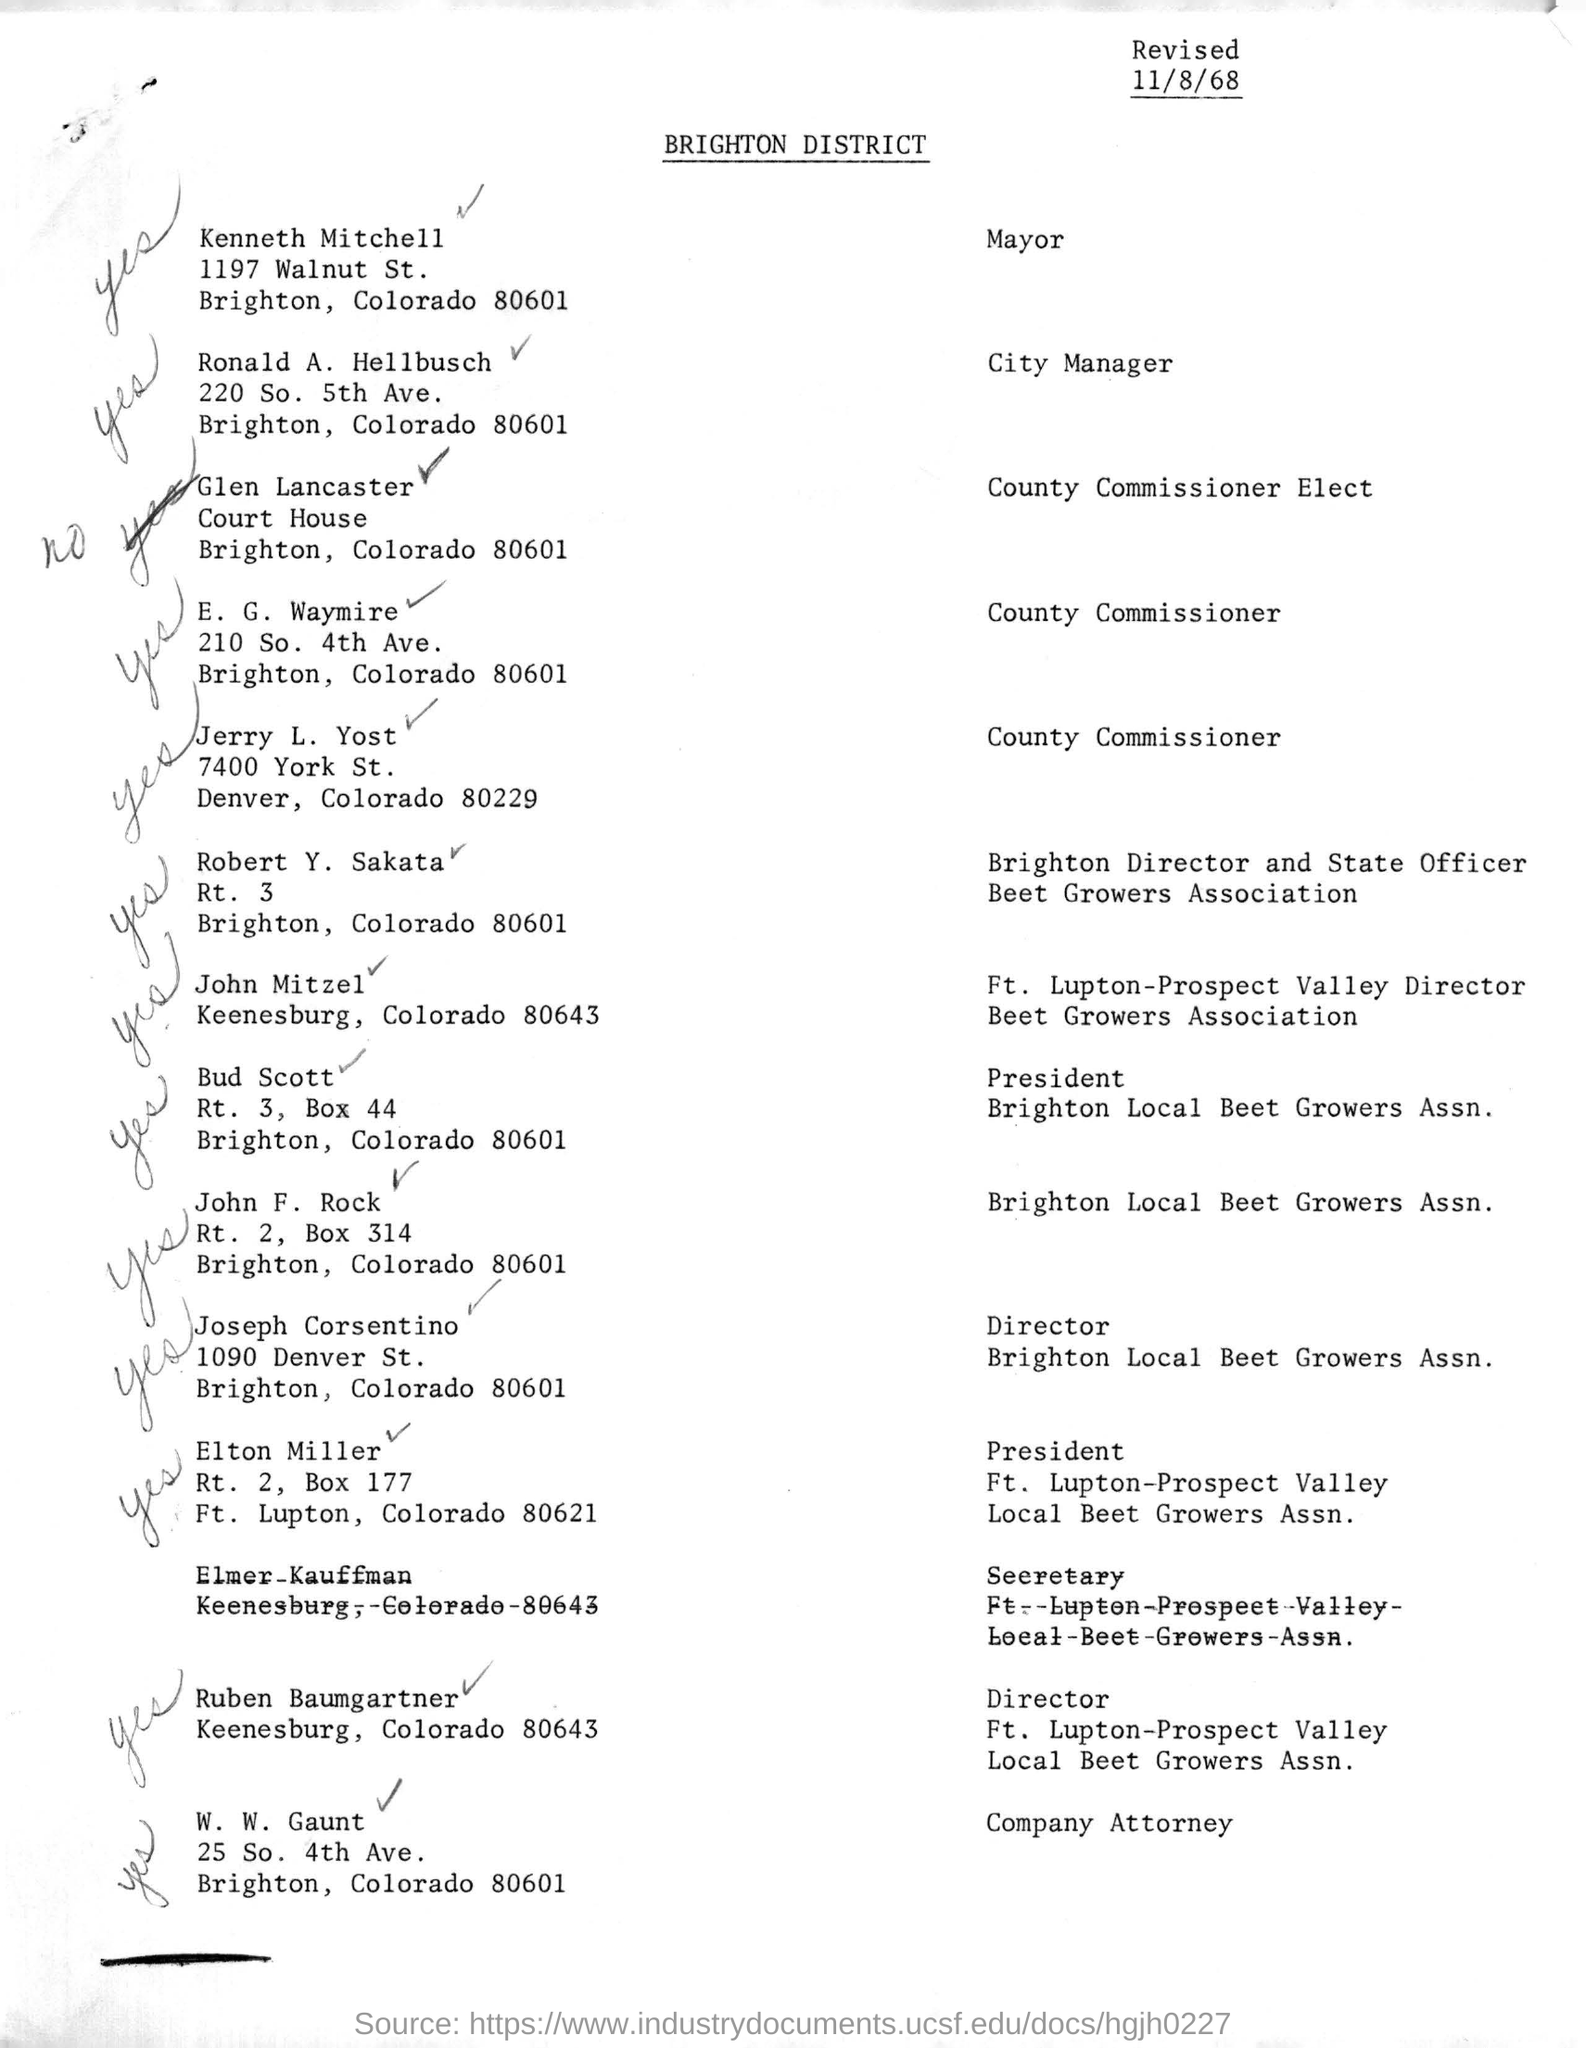Highlight a few significant elements in this photo. The date mentioned in the header is 11/8/68. The street address of Joseph Corsentino is 1090 Denver Street. The designation of Kenneth Mitchell is Mayor. 